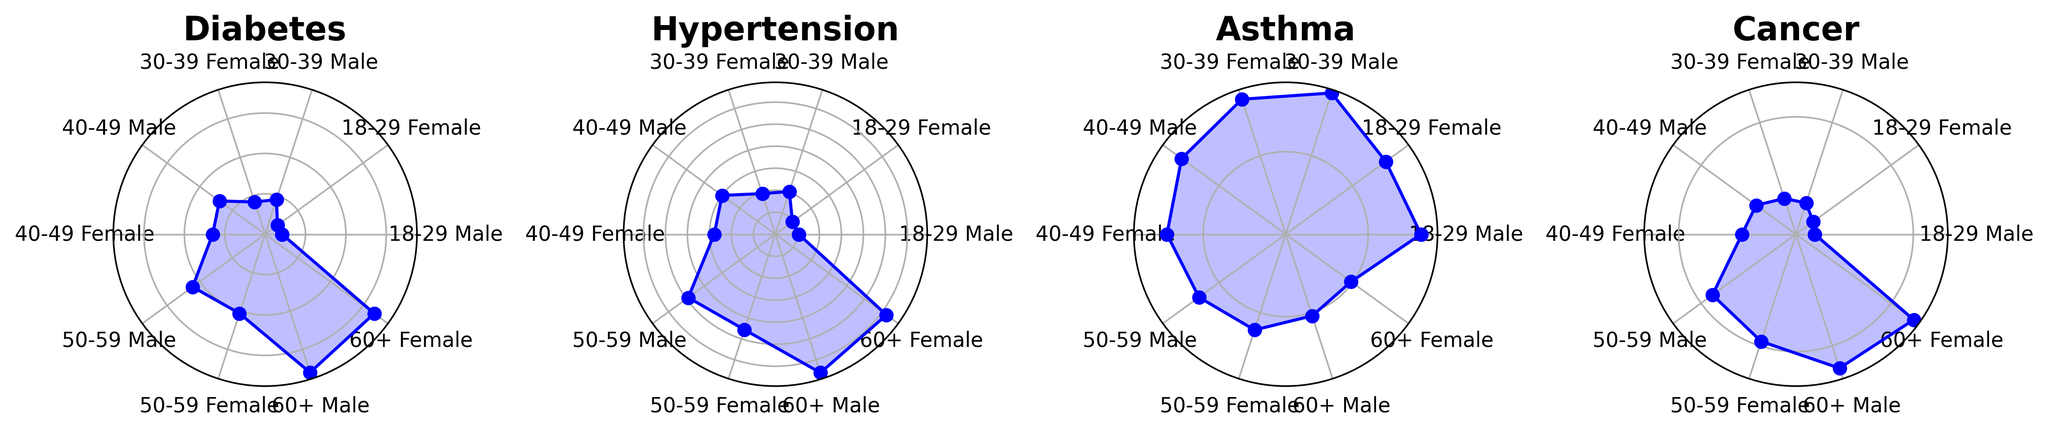Which gender has a higher prevalence of diabetes in the 50-59 age group? To answer, locate the Diabetes chart and compare the lengths of lines corresponding to Males and Females in the 50-59 age group. The line for Males is longer.
Answer: Male Which disease has the highest overall prevalence across all demographic groups? By visually comparing the heights/lengths of all lines for each disease in their respective charts, Hypertension has the longest lengths on average, indicating the highest prevalence overall.
Answer: Hypertension What is the average prevalence of Asthma for Females aged 30-39 and 40-49? Locate the Asthma chart and find the prevalence percentages for Females in the 30-39 and 40-49 age groups (8.6 and 7.2). Add them and divide by 2. (8.6 + 7.2)/2 = 7.9
Answer: 7.9 Does the prevalence of cancer increase or decrease with age? Examine the Cancer chart for both genders and notice that the prevalence percentage increases as you move from younger to older age groups.
Answer: Increase For which age group does Hypertension have the largest gender difference in prevalence, and what is the difference? In the Hypertension chart, the largest difference between Male and Female prevalence appears in the 50-59 age group. The difference is calculated as 24.5 - 22.8 = 1.7.
Answer: 50-59, 1.7 What is the total prevalence of diabetes for all age groups combined for males? Add the percentages for Males in all age groups from the Diabetes chart: 2.1 + 4.5 + 7.0 + 11.1 + 18.0 = 42.7
Answer: 42.7 Which age group has the highest prevalence of Asthma for Males, and what is that percentage? Look at the Asthma chart and find the peak prevalence for Males, which is in the 30-39 age group at 9.0%.
Answer: 30-39, 9.0 Compare the prevalence of cancer between Males and Females in the 60+ age group. In the Cancer chart, the prevalence for Males is 6.0%, and for Females, it is 6.2%. So, Females have a slightly higher prevalence.
Answer: Females have a higher prevalence Which disease shows the most significant increase in prevalence from the youngest to the oldest age group? Compare the rise in prevalence from the youngest to the oldest age group across all disease charts. Hypertension shows the largest increase.
Answer: Hypertension What's the sum of the prevalence percentages of Hypertension for Females aged 18-29, 30-39, and 40-49? In the Hypertension chart, add the prevalence percentages for Females in the specified age groups: 4.8 + 9.7 + 13.9 = 28.4
Answer: 28.4 